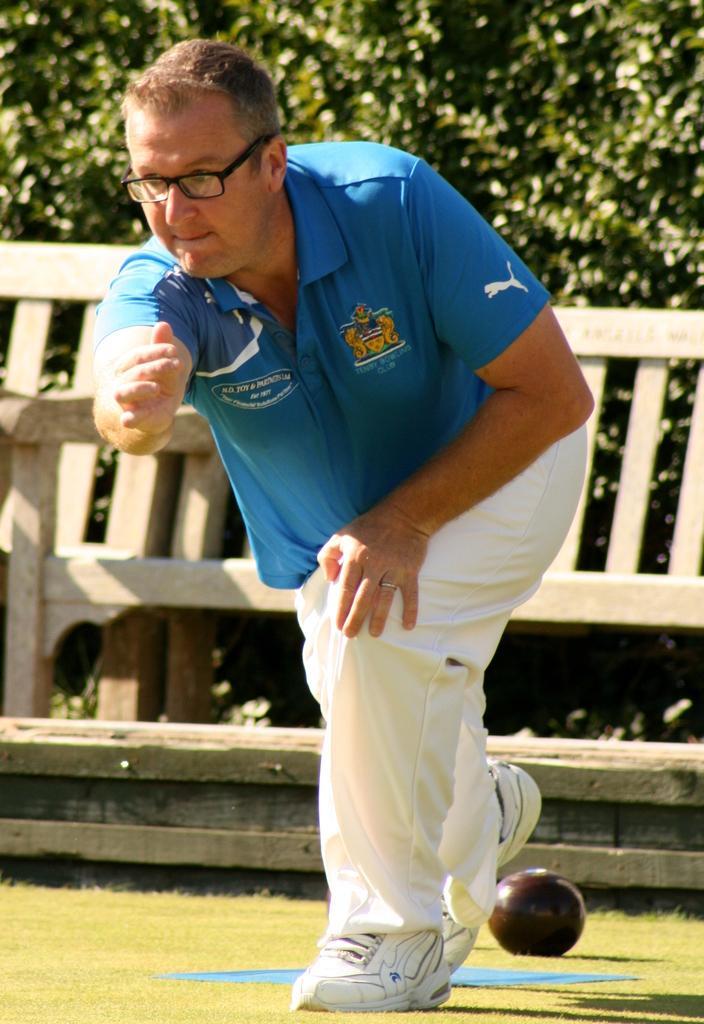Could you give a brief overview of what you see in this image? This picture is clicked outside. In the center we can see a person wearing blue color T-shirt and we can see a ball and some other object on the green grass. In the background, we can see the wooden bench and the green leaves. 